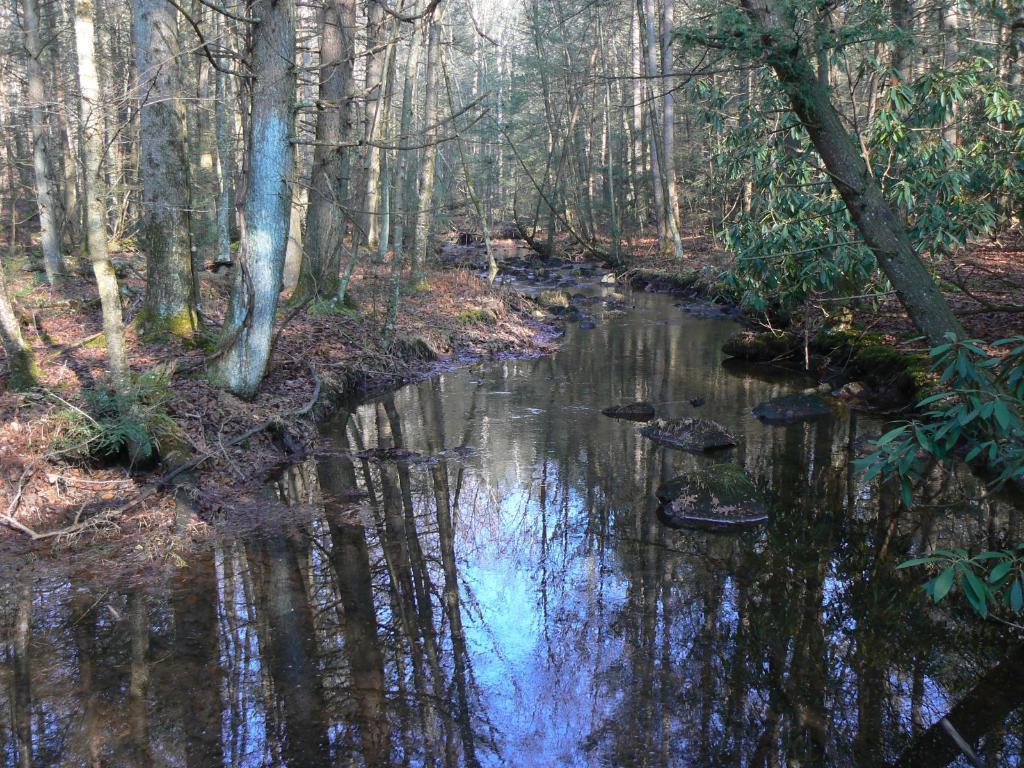Can you describe this image briefly? In this image we can see water and trees. On the water we can see the reflection of trees and sky. 